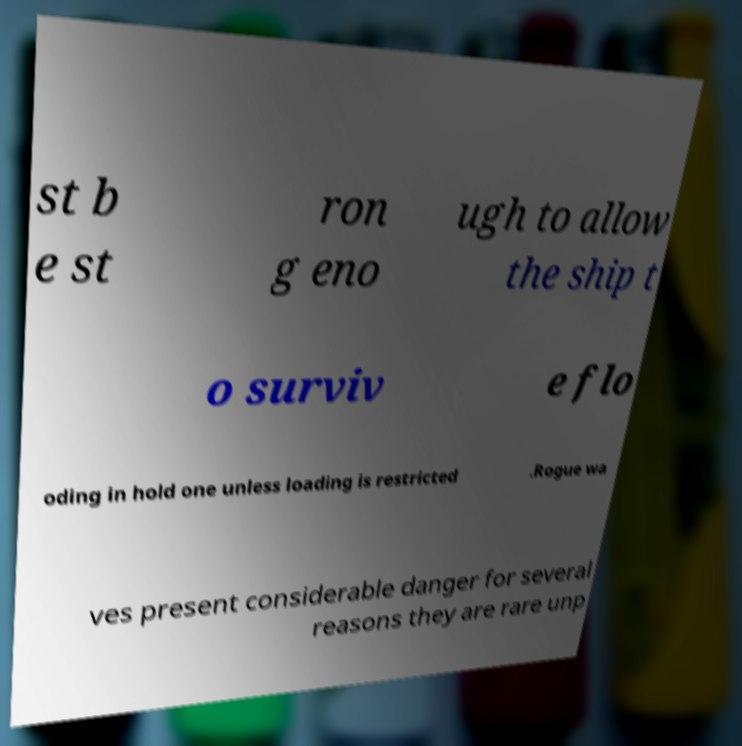For documentation purposes, I need the text within this image transcribed. Could you provide that? st b e st ron g eno ugh to allow the ship t o surviv e flo oding in hold one unless loading is restricted .Rogue wa ves present considerable danger for several reasons they are rare unp 